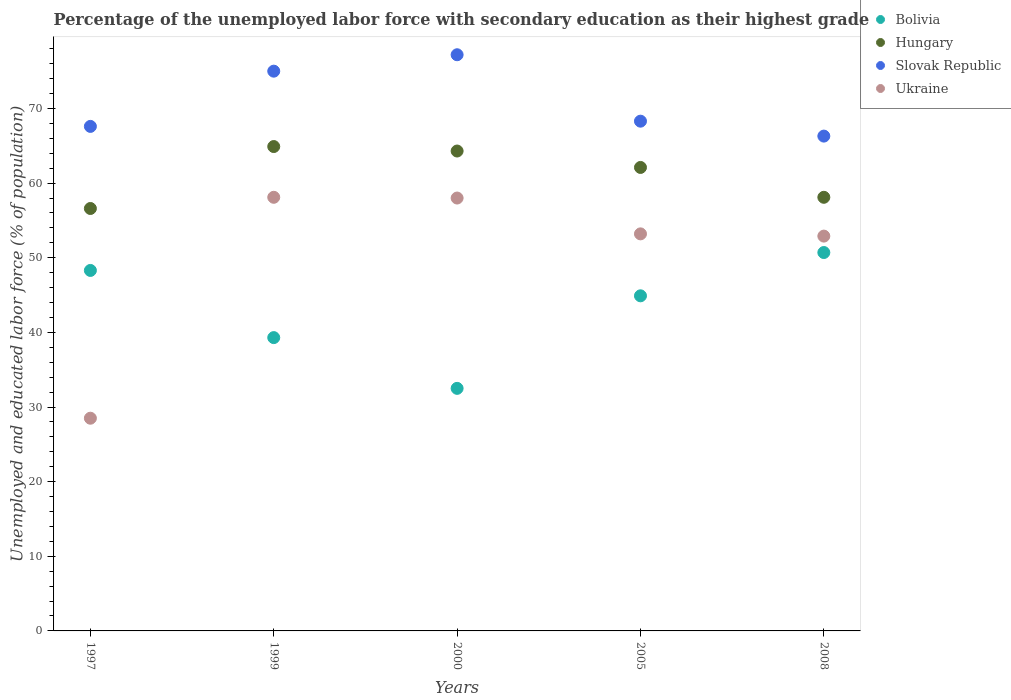What is the percentage of the unemployed labor force with secondary education in Ukraine in 2000?
Offer a terse response. 58. Across all years, what is the maximum percentage of the unemployed labor force with secondary education in Ukraine?
Your response must be concise. 58.1. Across all years, what is the minimum percentage of the unemployed labor force with secondary education in Bolivia?
Provide a short and direct response. 32.5. In which year was the percentage of the unemployed labor force with secondary education in Bolivia minimum?
Provide a succinct answer. 2000. What is the total percentage of the unemployed labor force with secondary education in Slovak Republic in the graph?
Your answer should be compact. 354.4. What is the difference between the percentage of the unemployed labor force with secondary education in Ukraine in 2005 and the percentage of the unemployed labor force with secondary education in Bolivia in 2008?
Provide a short and direct response. 2.5. What is the average percentage of the unemployed labor force with secondary education in Bolivia per year?
Offer a terse response. 43.14. In the year 1997, what is the difference between the percentage of the unemployed labor force with secondary education in Bolivia and percentage of the unemployed labor force with secondary education in Slovak Republic?
Give a very brief answer. -19.3. In how many years, is the percentage of the unemployed labor force with secondary education in Slovak Republic greater than 72 %?
Offer a terse response. 2. What is the ratio of the percentage of the unemployed labor force with secondary education in Ukraine in 2005 to that in 2008?
Your answer should be very brief. 1.01. Is the percentage of the unemployed labor force with secondary education in Hungary in 1997 less than that in 2000?
Give a very brief answer. Yes. What is the difference between the highest and the second highest percentage of the unemployed labor force with secondary education in Bolivia?
Offer a very short reply. 2.4. What is the difference between the highest and the lowest percentage of the unemployed labor force with secondary education in Slovak Republic?
Give a very brief answer. 10.9. Does the percentage of the unemployed labor force with secondary education in Ukraine monotonically increase over the years?
Ensure brevity in your answer.  No. Is the percentage of the unemployed labor force with secondary education in Ukraine strictly less than the percentage of the unemployed labor force with secondary education in Hungary over the years?
Offer a terse response. Yes. How many years are there in the graph?
Provide a succinct answer. 5. What is the difference between two consecutive major ticks on the Y-axis?
Your answer should be compact. 10. Does the graph contain any zero values?
Provide a succinct answer. No. Does the graph contain grids?
Offer a terse response. No. How many legend labels are there?
Provide a short and direct response. 4. What is the title of the graph?
Ensure brevity in your answer.  Percentage of the unemployed labor force with secondary education as their highest grade. Does "Zimbabwe" appear as one of the legend labels in the graph?
Make the answer very short. No. What is the label or title of the X-axis?
Your answer should be very brief. Years. What is the label or title of the Y-axis?
Your answer should be compact. Unemployed and educated labor force (% of population). What is the Unemployed and educated labor force (% of population) in Bolivia in 1997?
Your answer should be compact. 48.3. What is the Unemployed and educated labor force (% of population) of Hungary in 1997?
Your answer should be compact. 56.6. What is the Unemployed and educated labor force (% of population) of Slovak Republic in 1997?
Ensure brevity in your answer.  67.6. What is the Unemployed and educated labor force (% of population) in Ukraine in 1997?
Make the answer very short. 28.5. What is the Unemployed and educated labor force (% of population) of Bolivia in 1999?
Make the answer very short. 39.3. What is the Unemployed and educated labor force (% of population) in Hungary in 1999?
Provide a short and direct response. 64.9. What is the Unemployed and educated labor force (% of population) of Slovak Republic in 1999?
Offer a terse response. 75. What is the Unemployed and educated labor force (% of population) of Ukraine in 1999?
Your answer should be very brief. 58.1. What is the Unemployed and educated labor force (% of population) in Bolivia in 2000?
Provide a short and direct response. 32.5. What is the Unemployed and educated labor force (% of population) in Hungary in 2000?
Provide a short and direct response. 64.3. What is the Unemployed and educated labor force (% of population) of Slovak Republic in 2000?
Offer a terse response. 77.2. What is the Unemployed and educated labor force (% of population) in Bolivia in 2005?
Your answer should be very brief. 44.9. What is the Unemployed and educated labor force (% of population) in Hungary in 2005?
Ensure brevity in your answer.  62.1. What is the Unemployed and educated labor force (% of population) of Slovak Republic in 2005?
Your answer should be very brief. 68.3. What is the Unemployed and educated labor force (% of population) of Ukraine in 2005?
Your answer should be compact. 53.2. What is the Unemployed and educated labor force (% of population) in Bolivia in 2008?
Your response must be concise. 50.7. What is the Unemployed and educated labor force (% of population) of Hungary in 2008?
Provide a short and direct response. 58.1. What is the Unemployed and educated labor force (% of population) of Slovak Republic in 2008?
Provide a short and direct response. 66.3. What is the Unemployed and educated labor force (% of population) of Ukraine in 2008?
Ensure brevity in your answer.  52.9. Across all years, what is the maximum Unemployed and educated labor force (% of population) of Bolivia?
Provide a short and direct response. 50.7. Across all years, what is the maximum Unemployed and educated labor force (% of population) in Hungary?
Offer a very short reply. 64.9. Across all years, what is the maximum Unemployed and educated labor force (% of population) of Slovak Republic?
Give a very brief answer. 77.2. Across all years, what is the maximum Unemployed and educated labor force (% of population) in Ukraine?
Provide a short and direct response. 58.1. Across all years, what is the minimum Unemployed and educated labor force (% of population) in Bolivia?
Make the answer very short. 32.5. Across all years, what is the minimum Unemployed and educated labor force (% of population) in Hungary?
Make the answer very short. 56.6. Across all years, what is the minimum Unemployed and educated labor force (% of population) in Slovak Republic?
Provide a succinct answer. 66.3. What is the total Unemployed and educated labor force (% of population) of Bolivia in the graph?
Provide a short and direct response. 215.7. What is the total Unemployed and educated labor force (% of population) in Hungary in the graph?
Your response must be concise. 306. What is the total Unemployed and educated labor force (% of population) in Slovak Republic in the graph?
Keep it short and to the point. 354.4. What is the total Unemployed and educated labor force (% of population) in Ukraine in the graph?
Keep it short and to the point. 250.7. What is the difference between the Unemployed and educated labor force (% of population) in Bolivia in 1997 and that in 1999?
Make the answer very short. 9. What is the difference between the Unemployed and educated labor force (% of population) in Hungary in 1997 and that in 1999?
Your answer should be compact. -8.3. What is the difference between the Unemployed and educated labor force (% of population) of Slovak Republic in 1997 and that in 1999?
Provide a short and direct response. -7.4. What is the difference between the Unemployed and educated labor force (% of population) of Ukraine in 1997 and that in 1999?
Provide a short and direct response. -29.6. What is the difference between the Unemployed and educated labor force (% of population) of Slovak Republic in 1997 and that in 2000?
Provide a succinct answer. -9.6. What is the difference between the Unemployed and educated labor force (% of population) of Ukraine in 1997 and that in 2000?
Offer a terse response. -29.5. What is the difference between the Unemployed and educated labor force (% of population) of Slovak Republic in 1997 and that in 2005?
Ensure brevity in your answer.  -0.7. What is the difference between the Unemployed and educated labor force (% of population) of Ukraine in 1997 and that in 2005?
Provide a succinct answer. -24.7. What is the difference between the Unemployed and educated labor force (% of population) in Slovak Republic in 1997 and that in 2008?
Your answer should be very brief. 1.3. What is the difference between the Unemployed and educated labor force (% of population) in Ukraine in 1997 and that in 2008?
Make the answer very short. -24.4. What is the difference between the Unemployed and educated labor force (% of population) in Bolivia in 1999 and that in 2000?
Offer a terse response. 6.8. What is the difference between the Unemployed and educated labor force (% of population) in Ukraine in 1999 and that in 2000?
Offer a very short reply. 0.1. What is the difference between the Unemployed and educated labor force (% of population) of Bolivia in 1999 and that in 2005?
Give a very brief answer. -5.6. What is the difference between the Unemployed and educated labor force (% of population) in Ukraine in 1999 and that in 2005?
Offer a terse response. 4.9. What is the difference between the Unemployed and educated labor force (% of population) in Bolivia in 1999 and that in 2008?
Keep it short and to the point. -11.4. What is the difference between the Unemployed and educated labor force (% of population) in Hungary in 1999 and that in 2008?
Make the answer very short. 6.8. What is the difference between the Unemployed and educated labor force (% of population) in Slovak Republic in 1999 and that in 2008?
Keep it short and to the point. 8.7. What is the difference between the Unemployed and educated labor force (% of population) of Ukraine in 1999 and that in 2008?
Provide a succinct answer. 5.2. What is the difference between the Unemployed and educated labor force (% of population) in Bolivia in 2000 and that in 2005?
Offer a terse response. -12.4. What is the difference between the Unemployed and educated labor force (% of population) in Bolivia in 2000 and that in 2008?
Ensure brevity in your answer.  -18.2. What is the difference between the Unemployed and educated labor force (% of population) of Hungary in 2000 and that in 2008?
Your answer should be very brief. 6.2. What is the difference between the Unemployed and educated labor force (% of population) of Ukraine in 2000 and that in 2008?
Ensure brevity in your answer.  5.1. What is the difference between the Unemployed and educated labor force (% of population) in Ukraine in 2005 and that in 2008?
Provide a short and direct response. 0.3. What is the difference between the Unemployed and educated labor force (% of population) in Bolivia in 1997 and the Unemployed and educated labor force (% of population) in Hungary in 1999?
Offer a terse response. -16.6. What is the difference between the Unemployed and educated labor force (% of population) of Bolivia in 1997 and the Unemployed and educated labor force (% of population) of Slovak Republic in 1999?
Ensure brevity in your answer.  -26.7. What is the difference between the Unemployed and educated labor force (% of population) of Bolivia in 1997 and the Unemployed and educated labor force (% of population) of Ukraine in 1999?
Offer a very short reply. -9.8. What is the difference between the Unemployed and educated labor force (% of population) of Hungary in 1997 and the Unemployed and educated labor force (% of population) of Slovak Republic in 1999?
Your answer should be very brief. -18.4. What is the difference between the Unemployed and educated labor force (% of population) in Hungary in 1997 and the Unemployed and educated labor force (% of population) in Ukraine in 1999?
Your answer should be very brief. -1.5. What is the difference between the Unemployed and educated labor force (% of population) in Slovak Republic in 1997 and the Unemployed and educated labor force (% of population) in Ukraine in 1999?
Offer a very short reply. 9.5. What is the difference between the Unemployed and educated labor force (% of population) in Bolivia in 1997 and the Unemployed and educated labor force (% of population) in Slovak Republic in 2000?
Provide a succinct answer. -28.9. What is the difference between the Unemployed and educated labor force (% of population) in Bolivia in 1997 and the Unemployed and educated labor force (% of population) in Ukraine in 2000?
Your answer should be very brief. -9.7. What is the difference between the Unemployed and educated labor force (% of population) in Hungary in 1997 and the Unemployed and educated labor force (% of population) in Slovak Republic in 2000?
Keep it short and to the point. -20.6. What is the difference between the Unemployed and educated labor force (% of population) in Hungary in 1997 and the Unemployed and educated labor force (% of population) in Ukraine in 2000?
Provide a short and direct response. -1.4. What is the difference between the Unemployed and educated labor force (% of population) of Bolivia in 1997 and the Unemployed and educated labor force (% of population) of Hungary in 2005?
Your response must be concise. -13.8. What is the difference between the Unemployed and educated labor force (% of population) in Bolivia in 1997 and the Unemployed and educated labor force (% of population) in Slovak Republic in 2005?
Give a very brief answer. -20. What is the difference between the Unemployed and educated labor force (% of population) in Bolivia in 1997 and the Unemployed and educated labor force (% of population) in Ukraine in 2005?
Offer a very short reply. -4.9. What is the difference between the Unemployed and educated labor force (% of population) of Bolivia in 1997 and the Unemployed and educated labor force (% of population) of Hungary in 2008?
Your answer should be very brief. -9.8. What is the difference between the Unemployed and educated labor force (% of population) of Hungary in 1997 and the Unemployed and educated labor force (% of population) of Slovak Republic in 2008?
Your answer should be compact. -9.7. What is the difference between the Unemployed and educated labor force (% of population) of Bolivia in 1999 and the Unemployed and educated labor force (% of population) of Hungary in 2000?
Make the answer very short. -25. What is the difference between the Unemployed and educated labor force (% of population) of Bolivia in 1999 and the Unemployed and educated labor force (% of population) of Slovak Republic in 2000?
Your response must be concise. -37.9. What is the difference between the Unemployed and educated labor force (% of population) in Bolivia in 1999 and the Unemployed and educated labor force (% of population) in Ukraine in 2000?
Give a very brief answer. -18.7. What is the difference between the Unemployed and educated labor force (% of population) of Slovak Republic in 1999 and the Unemployed and educated labor force (% of population) of Ukraine in 2000?
Offer a terse response. 17. What is the difference between the Unemployed and educated labor force (% of population) of Bolivia in 1999 and the Unemployed and educated labor force (% of population) of Hungary in 2005?
Offer a terse response. -22.8. What is the difference between the Unemployed and educated labor force (% of population) in Bolivia in 1999 and the Unemployed and educated labor force (% of population) in Slovak Republic in 2005?
Make the answer very short. -29. What is the difference between the Unemployed and educated labor force (% of population) of Hungary in 1999 and the Unemployed and educated labor force (% of population) of Slovak Republic in 2005?
Keep it short and to the point. -3.4. What is the difference between the Unemployed and educated labor force (% of population) in Slovak Republic in 1999 and the Unemployed and educated labor force (% of population) in Ukraine in 2005?
Provide a short and direct response. 21.8. What is the difference between the Unemployed and educated labor force (% of population) of Bolivia in 1999 and the Unemployed and educated labor force (% of population) of Hungary in 2008?
Keep it short and to the point. -18.8. What is the difference between the Unemployed and educated labor force (% of population) of Bolivia in 1999 and the Unemployed and educated labor force (% of population) of Ukraine in 2008?
Provide a succinct answer. -13.6. What is the difference between the Unemployed and educated labor force (% of population) in Hungary in 1999 and the Unemployed and educated labor force (% of population) in Ukraine in 2008?
Your response must be concise. 12. What is the difference between the Unemployed and educated labor force (% of population) in Slovak Republic in 1999 and the Unemployed and educated labor force (% of population) in Ukraine in 2008?
Offer a terse response. 22.1. What is the difference between the Unemployed and educated labor force (% of population) in Bolivia in 2000 and the Unemployed and educated labor force (% of population) in Hungary in 2005?
Provide a succinct answer. -29.6. What is the difference between the Unemployed and educated labor force (% of population) of Bolivia in 2000 and the Unemployed and educated labor force (% of population) of Slovak Republic in 2005?
Ensure brevity in your answer.  -35.8. What is the difference between the Unemployed and educated labor force (% of population) in Bolivia in 2000 and the Unemployed and educated labor force (% of population) in Ukraine in 2005?
Provide a succinct answer. -20.7. What is the difference between the Unemployed and educated labor force (% of population) in Hungary in 2000 and the Unemployed and educated labor force (% of population) in Slovak Republic in 2005?
Provide a short and direct response. -4. What is the difference between the Unemployed and educated labor force (% of population) of Bolivia in 2000 and the Unemployed and educated labor force (% of population) of Hungary in 2008?
Your answer should be compact. -25.6. What is the difference between the Unemployed and educated labor force (% of population) in Bolivia in 2000 and the Unemployed and educated labor force (% of population) in Slovak Republic in 2008?
Your answer should be compact. -33.8. What is the difference between the Unemployed and educated labor force (% of population) in Bolivia in 2000 and the Unemployed and educated labor force (% of population) in Ukraine in 2008?
Your answer should be very brief. -20.4. What is the difference between the Unemployed and educated labor force (% of population) of Hungary in 2000 and the Unemployed and educated labor force (% of population) of Slovak Republic in 2008?
Keep it short and to the point. -2. What is the difference between the Unemployed and educated labor force (% of population) in Hungary in 2000 and the Unemployed and educated labor force (% of population) in Ukraine in 2008?
Offer a very short reply. 11.4. What is the difference between the Unemployed and educated labor force (% of population) of Slovak Republic in 2000 and the Unemployed and educated labor force (% of population) of Ukraine in 2008?
Offer a terse response. 24.3. What is the difference between the Unemployed and educated labor force (% of population) of Bolivia in 2005 and the Unemployed and educated labor force (% of population) of Slovak Republic in 2008?
Your response must be concise. -21.4. What is the difference between the Unemployed and educated labor force (% of population) in Hungary in 2005 and the Unemployed and educated labor force (% of population) in Slovak Republic in 2008?
Your answer should be very brief. -4.2. What is the difference between the Unemployed and educated labor force (% of population) of Slovak Republic in 2005 and the Unemployed and educated labor force (% of population) of Ukraine in 2008?
Your answer should be very brief. 15.4. What is the average Unemployed and educated labor force (% of population) in Bolivia per year?
Your answer should be very brief. 43.14. What is the average Unemployed and educated labor force (% of population) in Hungary per year?
Keep it short and to the point. 61.2. What is the average Unemployed and educated labor force (% of population) in Slovak Republic per year?
Provide a short and direct response. 70.88. What is the average Unemployed and educated labor force (% of population) of Ukraine per year?
Make the answer very short. 50.14. In the year 1997, what is the difference between the Unemployed and educated labor force (% of population) in Bolivia and Unemployed and educated labor force (% of population) in Hungary?
Ensure brevity in your answer.  -8.3. In the year 1997, what is the difference between the Unemployed and educated labor force (% of population) of Bolivia and Unemployed and educated labor force (% of population) of Slovak Republic?
Provide a short and direct response. -19.3. In the year 1997, what is the difference between the Unemployed and educated labor force (% of population) of Bolivia and Unemployed and educated labor force (% of population) of Ukraine?
Give a very brief answer. 19.8. In the year 1997, what is the difference between the Unemployed and educated labor force (% of population) in Hungary and Unemployed and educated labor force (% of population) in Ukraine?
Keep it short and to the point. 28.1. In the year 1997, what is the difference between the Unemployed and educated labor force (% of population) in Slovak Republic and Unemployed and educated labor force (% of population) in Ukraine?
Your answer should be very brief. 39.1. In the year 1999, what is the difference between the Unemployed and educated labor force (% of population) in Bolivia and Unemployed and educated labor force (% of population) in Hungary?
Make the answer very short. -25.6. In the year 1999, what is the difference between the Unemployed and educated labor force (% of population) of Bolivia and Unemployed and educated labor force (% of population) of Slovak Republic?
Your answer should be very brief. -35.7. In the year 1999, what is the difference between the Unemployed and educated labor force (% of population) in Bolivia and Unemployed and educated labor force (% of population) in Ukraine?
Your answer should be very brief. -18.8. In the year 1999, what is the difference between the Unemployed and educated labor force (% of population) of Hungary and Unemployed and educated labor force (% of population) of Slovak Republic?
Your response must be concise. -10.1. In the year 2000, what is the difference between the Unemployed and educated labor force (% of population) in Bolivia and Unemployed and educated labor force (% of population) in Hungary?
Make the answer very short. -31.8. In the year 2000, what is the difference between the Unemployed and educated labor force (% of population) of Bolivia and Unemployed and educated labor force (% of population) of Slovak Republic?
Provide a succinct answer. -44.7. In the year 2000, what is the difference between the Unemployed and educated labor force (% of population) of Bolivia and Unemployed and educated labor force (% of population) of Ukraine?
Ensure brevity in your answer.  -25.5. In the year 2000, what is the difference between the Unemployed and educated labor force (% of population) in Hungary and Unemployed and educated labor force (% of population) in Ukraine?
Keep it short and to the point. 6.3. In the year 2005, what is the difference between the Unemployed and educated labor force (% of population) of Bolivia and Unemployed and educated labor force (% of population) of Hungary?
Make the answer very short. -17.2. In the year 2005, what is the difference between the Unemployed and educated labor force (% of population) of Bolivia and Unemployed and educated labor force (% of population) of Slovak Republic?
Ensure brevity in your answer.  -23.4. In the year 2005, what is the difference between the Unemployed and educated labor force (% of population) in Bolivia and Unemployed and educated labor force (% of population) in Ukraine?
Provide a succinct answer. -8.3. In the year 2005, what is the difference between the Unemployed and educated labor force (% of population) in Hungary and Unemployed and educated labor force (% of population) in Ukraine?
Keep it short and to the point. 8.9. In the year 2005, what is the difference between the Unemployed and educated labor force (% of population) in Slovak Republic and Unemployed and educated labor force (% of population) in Ukraine?
Ensure brevity in your answer.  15.1. In the year 2008, what is the difference between the Unemployed and educated labor force (% of population) in Bolivia and Unemployed and educated labor force (% of population) in Hungary?
Your answer should be compact. -7.4. In the year 2008, what is the difference between the Unemployed and educated labor force (% of population) in Bolivia and Unemployed and educated labor force (% of population) in Slovak Republic?
Offer a very short reply. -15.6. In the year 2008, what is the difference between the Unemployed and educated labor force (% of population) of Bolivia and Unemployed and educated labor force (% of population) of Ukraine?
Ensure brevity in your answer.  -2.2. In the year 2008, what is the difference between the Unemployed and educated labor force (% of population) of Slovak Republic and Unemployed and educated labor force (% of population) of Ukraine?
Keep it short and to the point. 13.4. What is the ratio of the Unemployed and educated labor force (% of population) of Bolivia in 1997 to that in 1999?
Provide a succinct answer. 1.23. What is the ratio of the Unemployed and educated labor force (% of population) of Hungary in 1997 to that in 1999?
Your answer should be very brief. 0.87. What is the ratio of the Unemployed and educated labor force (% of population) in Slovak Republic in 1997 to that in 1999?
Keep it short and to the point. 0.9. What is the ratio of the Unemployed and educated labor force (% of population) in Ukraine in 1997 to that in 1999?
Make the answer very short. 0.49. What is the ratio of the Unemployed and educated labor force (% of population) of Bolivia in 1997 to that in 2000?
Offer a very short reply. 1.49. What is the ratio of the Unemployed and educated labor force (% of population) in Hungary in 1997 to that in 2000?
Your answer should be compact. 0.88. What is the ratio of the Unemployed and educated labor force (% of population) in Slovak Republic in 1997 to that in 2000?
Offer a very short reply. 0.88. What is the ratio of the Unemployed and educated labor force (% of population) of Ukraine in 1997 to that in 2000?
Keep it short and to the point. 0.49. What is the ratio of the Unemployed and educated labor force (% of population) in Bolivia in 1997 to that in 2005?
Keep it short and to the point. 1.08. What is the ratio of the Unemployed and educated labor force (% of population) of Hungary in 1997 to that in 2005?
Provide a succinct answer. 0.91. What is the ratio of the Unemployed and educated labor force (% of population) in Ukraine in 1997 to that in 2005?
Ensure brevity in your answer.  0.54. What is the ratio of the Unemployed and educated labor force (% of population) of Bolivia in 1997 to that in 2008?
Keep it short and to the point. 0.95. What is the ratio of the Unemployed and educated labor force (% of population) in Hungary in 1997 to that in 2008?
Make the answer very short. 0.97. What is the ratio of the Unemployed and educated labor force (% of population) of Slovak Republic in 1997 to that in 2008?
Your answer should be compact. 1.02. What is the ratio of the Unemployed and educated labor force (% of population) of Ukraine in 1997 to that in 2008?
Keep it short and to the point. 0.54. What is the ratio of the Unemployed and educated labor force (% of population) in Bolivia in 1999 to that in 2000?
Your answer should be compact. 1.21. What is the ratio of the Unemployed and educated labor force (% of population) in Hungary in 1999 to that in 2000?
Provide a succinct answer. 1.01. What is the ratio of the Unemployed and educated labor force (% of population) of Slovak Republic in 1999 to that in 2000?
Give a very brief answer. 0.97. What is the ratio of the Unemployed and educated labor force (% of population) of Bolivia in 1999 to that in 2005?
Your response must be concise. 0.88. What is the ratio of the Unemployed and educated labor force (% of population) in Hungary in 1999 to that in 2005?
Ensure brevity in your answer.  1.05. What is the ratio of the Unemployed and educated labor force (% of population) of Slovak Republic in 1999 to that in 2005?
Offer a terse response. 1.1. What is the ratio of the Unemployed and educated labor force (% of population) in Ukraine in 1999 to that in 2005?
Your answer should be very brief. 1.09. What is the ratio of the Unemployed and educated labor force (% of population) of Bolivia in 1999 to that in 2008?
Offer a terse response. 0.78. What is the ratio of the Unemployed and educated labor force (% of population) of Hungary in 1999 to that in 2008?
Give a very brief answer. 1.12. What is the ratio of the Unemployed and educated labor force (% of population) of Slovak Republic in 1999 to that in 2008?
Provide a succinct answer. 1.13. What is the ratio of the Unemployed and educated labor force (% of population) of Ukraine in 1999 to that in 2008?
Your answer should be compact. 1.1. What is the ratio of the Unemployed and educated labor force (% of population) of Bolivia in 2000 to that in 2005?
Ensure brevity in your answer.  0.72. What is the ratio of the Unemployed and educated labor force (% of population) in Hungary in 2000 to that in 2005?
Your response must be concise. 1.04. What is the ratio of the Unemployed and educated labor force (% of population) of Slovak Republic in 2000 to that in 2005?
Give a very brief answer. 1.13. What is the ratio of the Unemployed and educated labor force (% of population) in Ukraine in 2000 to that in 2005?
Your answer should be very brief. 1.09. What is the ratio of the Unemployed and educated labor force (% of population) of Bolivia in 2000 to that in 2008?
Provide a succinct answer. 0.64. What is the ratio of the Unemployed and educated labor force (% of population) in Hungary in 2000 to that in 2008?
Make the answer very short. 1.11. What is the ratio of the Unemployed and educated labor force (% of population) of Slovak Republic in 2000 to that in 2008?
Offer a very short reply. 1.16. What is the ratio of the Unemployed and educated labor force (% of population) in Ukraine in 2000 to that in 2008?
Ensure brevity in your answer.  1.1. What is the ratio of the Unemployed and educated labor force (% of population) in Bolivia in 2005 to that in 2008?
Give a very brief answer. 0.89. What is the ratio of the Unemployed and educated labor force (% of population) of Hungary in 2005 to that in 2008?
Provide a succinct answer. 1.07. What is the ratio of the Unemployed and educated labor force (% of population) of Slovak Republic in 2005 to that in 2008?
Your answer should be very brief. 1.03. What is the ratio of the Unemployed and educated labor force (% of population) in Ukraine in 2005 to that in 2008?
Provide a short and direct response. 1.01. What is the difference between the highest and the second highest Unemployed and educated labor force (% of population) of Bolivia?
Your response must be concise. 2.4. What is the difference between the highest and the second highest Unemployed and educated labor force (% of population) in Hungary?
Make the answer very short. 0.6. What is the difference between the highest and the lowest Unemployed and educated labor force (% of population) of Hungary?
Keep it short and to the point. 8.3. What is the difference between the highest and the lowest Unemployed and educated labor force (% of population) of Ukraine?
Provide a short and direct response. 29.6. 